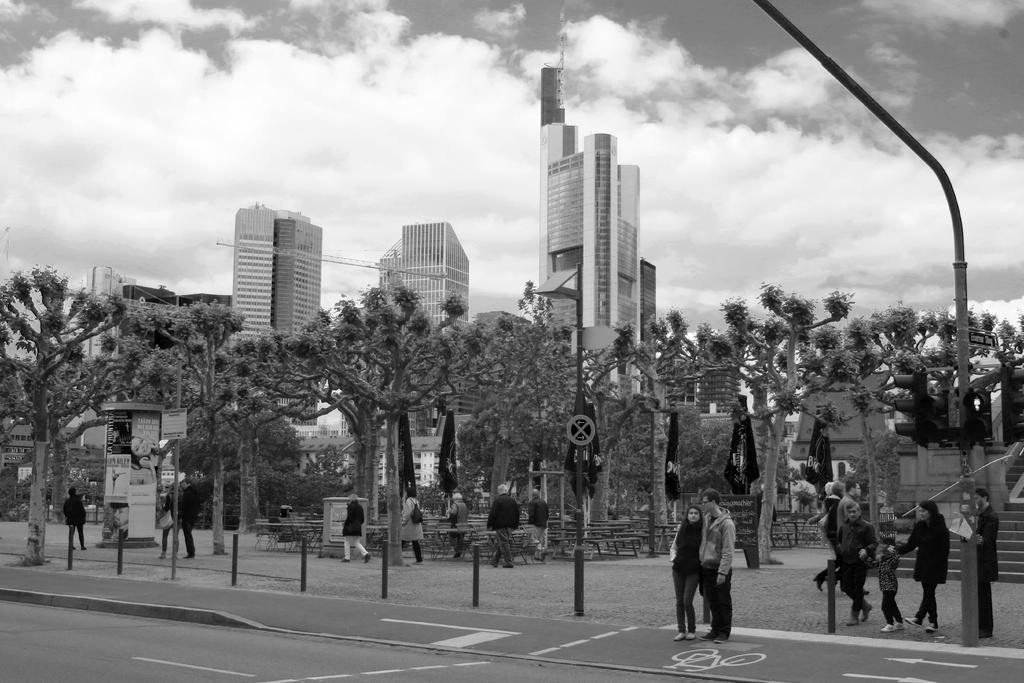Please provide a concise description of this image. In this picture I can see trees. I can see the traffic light pole. I can see a number of people on the surface. I can see the buildings in the background. I can see stairs on the right side. I can see the flags. I can see clouds in the sky. 